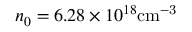<formula> <loc_0><loc_0><loc_500><loc_500>n _ { 0 } = 6 . 2 8 \times 1 0 ^ { 1 8 } { c m ^ { - 3 } }</formula> 